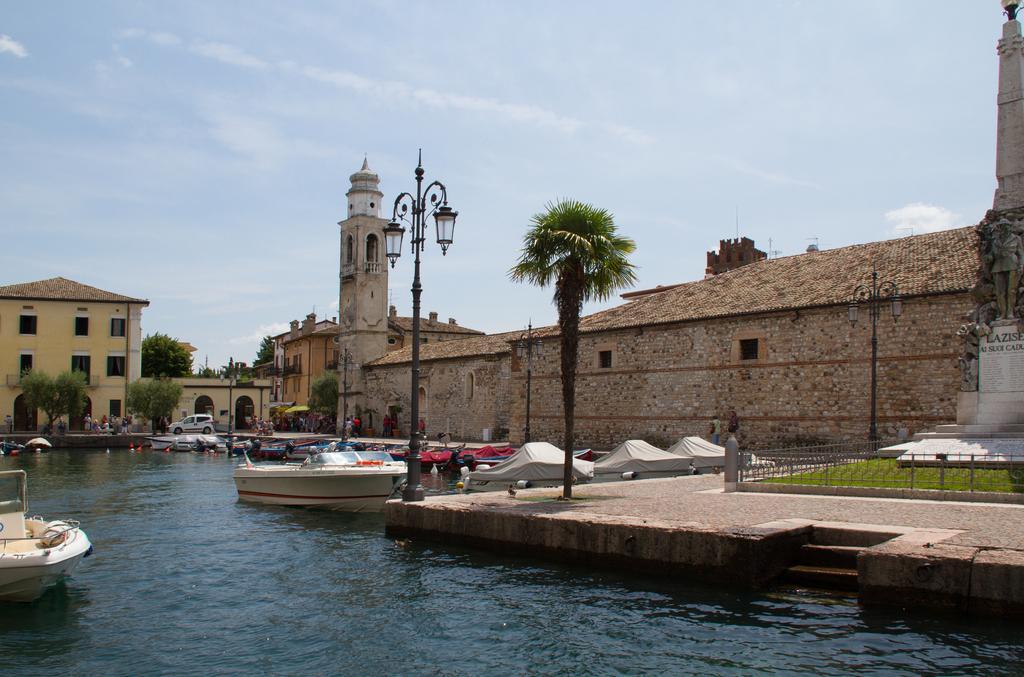Describe this image in one or two sentences. In this image I can see boats on the water. Here I can see fence, a statue, buildings, street lights and other objects. In the background I can see trees vehicle people and the sky 